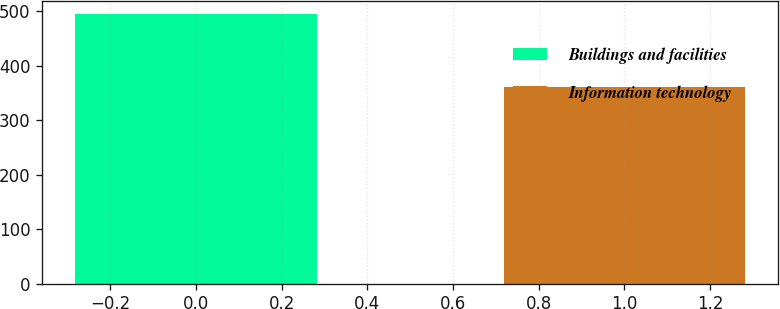Convert chart. <chart><loc_0><loc_0><loc_500><loc_500><bar_chart><fcel>Buildings and facilities<fcel>Information technology<nl><fcel>495<fcel>362<nl></chart> 